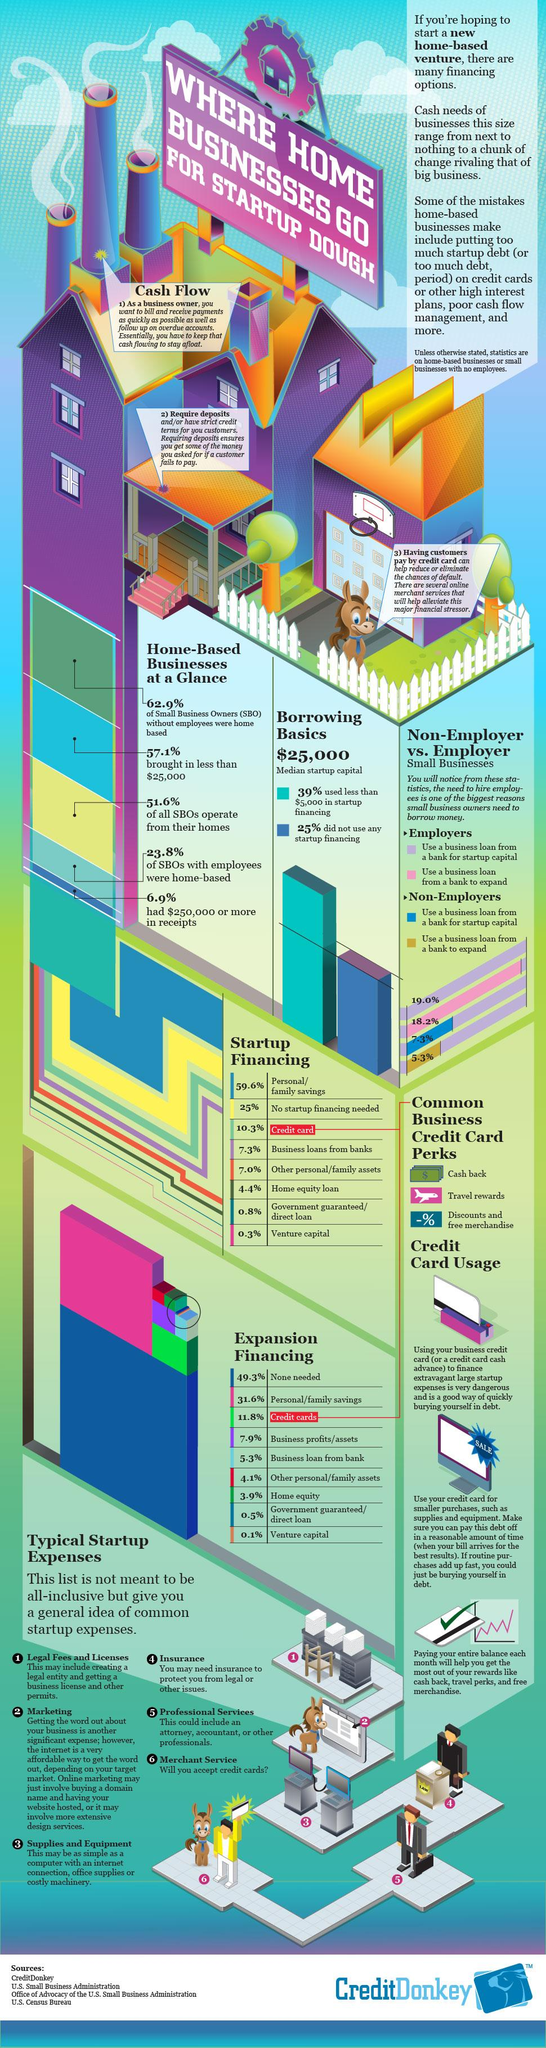Identify some key points in this picture. There are three advantages of credit cards listed in the infographic. Credit card usage offers several advantages, as stated in the info graphic. One such advantage is travel rewards, which is the second mentioned benefit. According to the data, a significant percentage of SBOs with employees are not based out of their homes. Specifically, 76.2% of these SBOs operate their businesses from a non-home-based location. Forty-two point nine percent of SBOs received startup financing of more than $25,000. According to the data, 93.1% of SBOs took less than $250,000 for startup financing. 